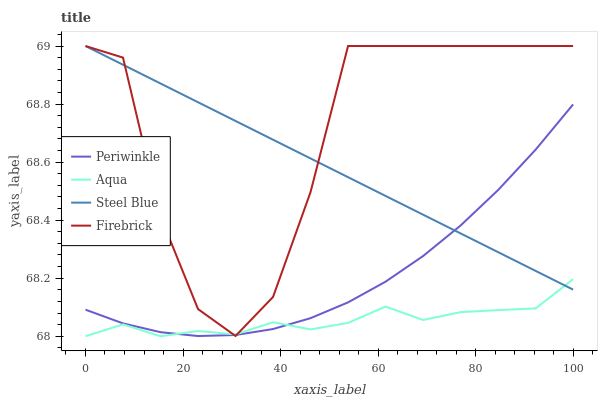Does Aqua have the minimum area under the curve?
Answer yes or no. Yes. Does Firebrick have the maximum area under the curve?
Answer yes or no. Yes. Does Periwinkle have the minimum area under the curve?
Answer yes or no. No. Does Periwinkle have the maximum area under the curve?
Answer yes or no. No. Is Steel Blue the smoothest?
Answer yes or no. Yes. Is Firebrick the roughest?
Answer yes or no. Yes. Is Periwinkle the smoothest?
Answer yes or no. No. Is Periwinkle the roughest?
Answer yes or no. No. Does Aqua have the lowest value?
Answer yes or no. Yes. Does Firebrick have the lowest value?
Answer yes or no. No. Does Steel Blue have the highest value?
Answer yes or no. Yes. Does Periwinkle have the highest value?
Answer yes or no. No. Does Periwinkle intersect Aqua?
Answer yes or no. Yes. Is Periwinkle less than Aqua?
Answer yes or no. No. Is Periwinkle greater than Aqua?
Answer yes or no. No. 